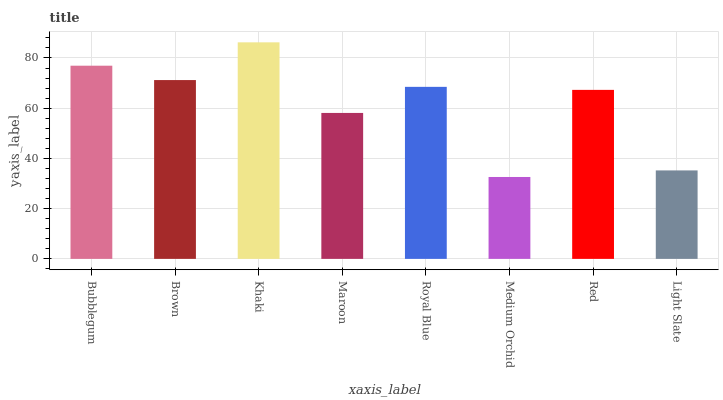Is Medium Orchid the minimum?
Answer yes or no. Yes. Is Khaki the maximum?
Answer yes or no. Yes. Is Brown the minimum?
Answer yes or no. No. Is Brown the maximum?
Answer yes or no. No. Is Bubblegum greater than Brown?
Answer yes or no. Yes. Is Brown less than Bubblegum?
Answer yes or no. Yes. Is Brown greater than Bubblegum?
Answer yes or no. No. Is Bubblegum less than Brown?
Answer yes or no. No. Is Royal Blue the high median?
Answer yes or no. Yes. Is Red the low median?
Answer yes or no. Yes. Is Brown the high median?
Answer yes or no. No. Is Royal Blue the low median?
Answer yes or no. No. 